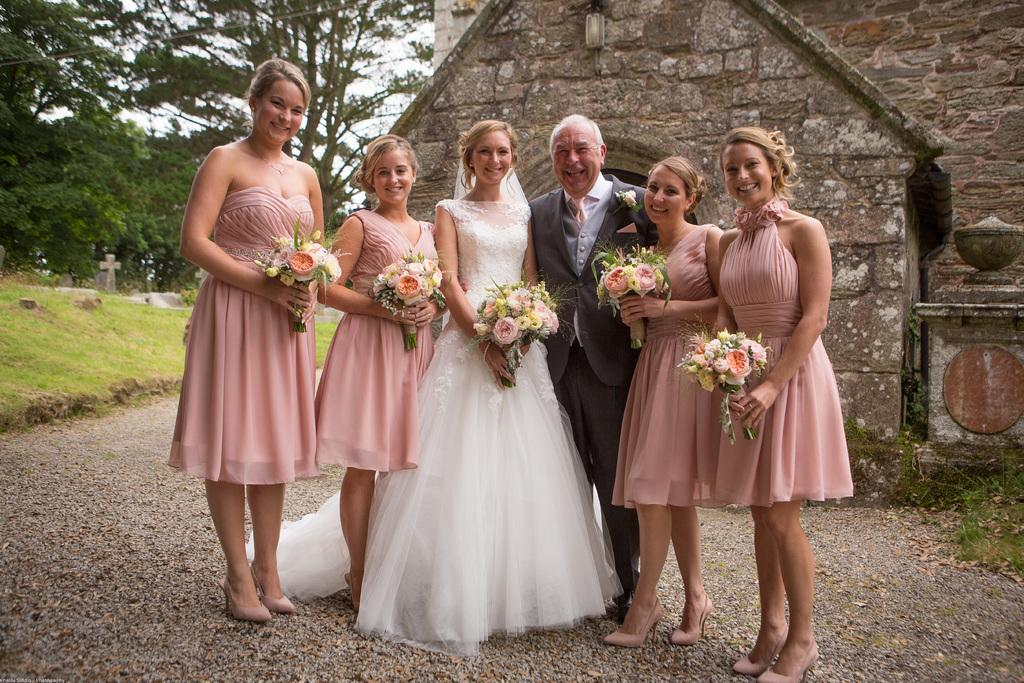Who or what can be seen in the image? There are people in the image. What is the surface that the people are standing on? The ground is visible in the image. What type of vegetation is present in the image? There is grass in the image. What structures or objects can be seen in the image? There are objects and a house in the image. What architectural feature is present in the image? There is a wall in the image. What else can be seen in the background of the image? There are trees and the sky visible in the image. What statement is being made by the basket in the image? There is no basket present in the image, so no statement can be made by a basket. 